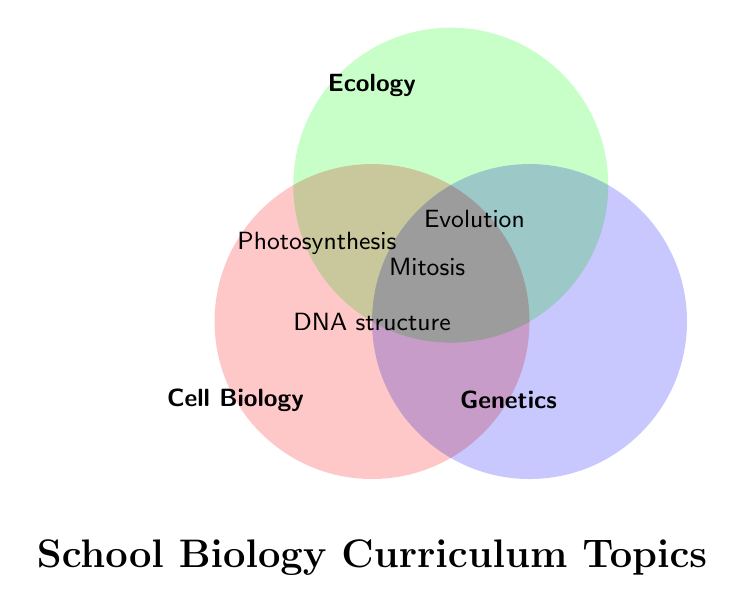What is the title of the Venn diagram? The title is usually placed at the top or bottom of the figure and describes its main subject. In this case, it is located at the bottom.
Answer: School Biology Curriculum Topics Which area represents "Ecology" in the Venn diagram? Identify the circles by their labels. The "Ecology" circle is the one at the top intersecting both other circles.
Answer: Top circle How many topics are present in the intersection of all three fields: Cell Biology, Ecology, and Genetics? Locate the center of the Venn diagram where all three circles overlap, and count the items listed there.
Answer: 1 Which topics are shared between Cell Biology and Ecology? Find the intersection area between the circles labeled "Cell Biology" and "Ecology" and read the topics listed there.
Answer: Photosynthesis Name one topic that is exclusively found in the Genetics area but not shared with Cell Biology or Ecology. Locate the Genetics circle and check areas of the circle that do not overlap with the other circles.
Answer: None What topics are associated with Genetics and Ecology, but not with Cell Biology? Check the intersection area between the circles labeled "Genetics" and "Ecology" that does not overlap with Cell Biology.
Answer: Evolution Is "Mitosis" a topic included in multiple biology fields? If so, which ones? Find "Mitosis" in the Venn diagram and note the circles it overlaps with.
Answer: Yes, Cell Biology and Genetics Compare the number of topics shared by Cell Biology and Genetics with those shared by Ecology and Genetics. Which is greater? Count the topics in the intersections of Cell Biology and Genetics, then count the topics in the intersection of Ecology and Genetics. Compare the counts.
Answer: Cell Biology and Genetics What field shares the most topics with Genetics? Compare the number of shared topics between Genetics and the other two fields by counting their intersection areas.
Answer: Cell Biology Which subject area has the least intersection with Ecology? Count the number of topics in the intersection areas between Ecology and Cell Biology, and Ecology and Genetics, then compare.
Answer: Genetics 